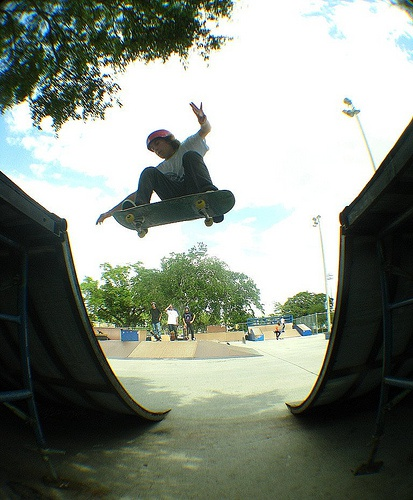Describe the objects in this image and their specific colors. I can see people in black, gray, and purple tones, skateboard in black, gray, and teal tones, people in black, gray, darkgreen, and khaki tones, people in black, darkgreen, and gray tones, and people in black, white, gray, and tan tones in this image. 